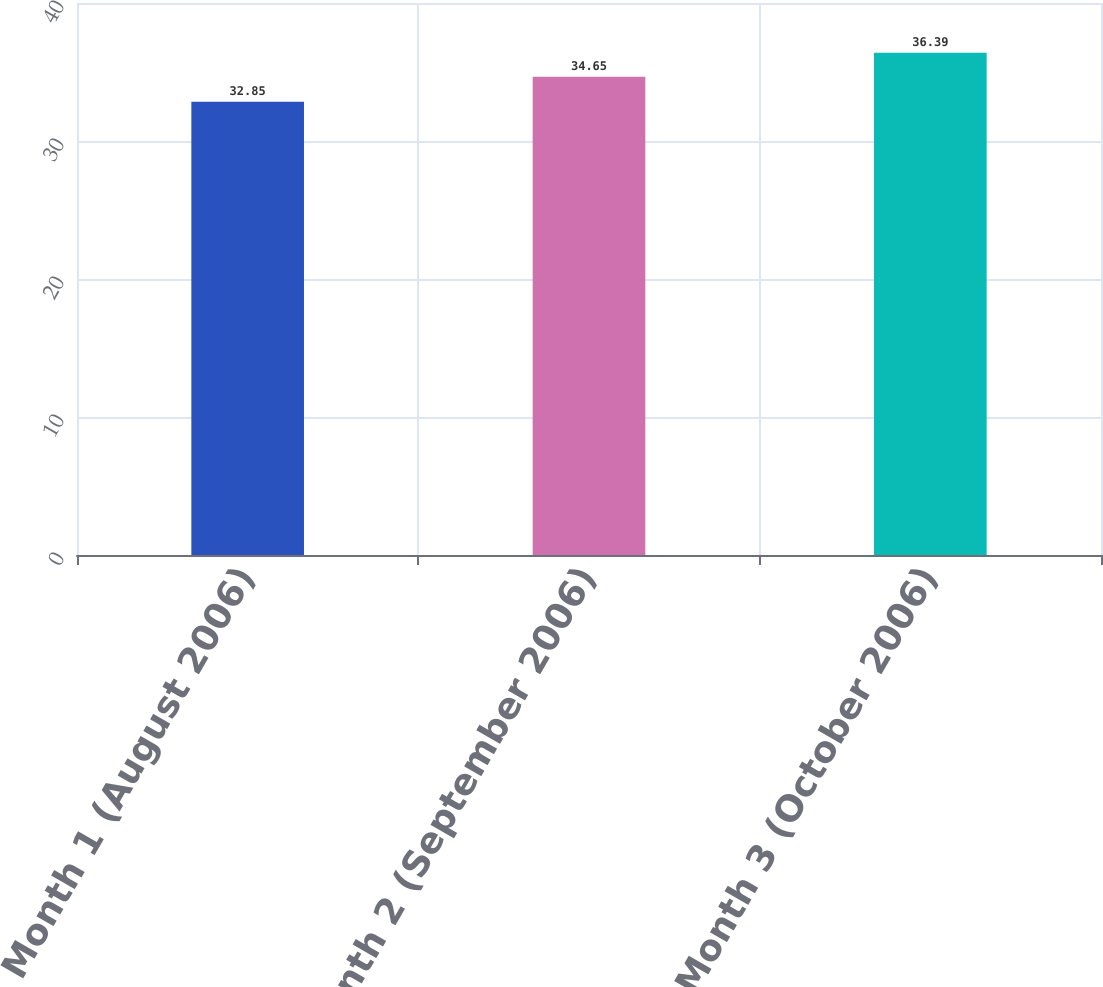Convert chart to OTSL. <chart><loc_0><loc_0><loc_500><loc_500><bar_chart><fcel>Month 1 (August 2006)<fcel>Month 2 (September 2006)<fcel>Month 3 (October 2006)<nl><fcel>32.85<fcel>34.65<fcel>36.39<nl></chart> 